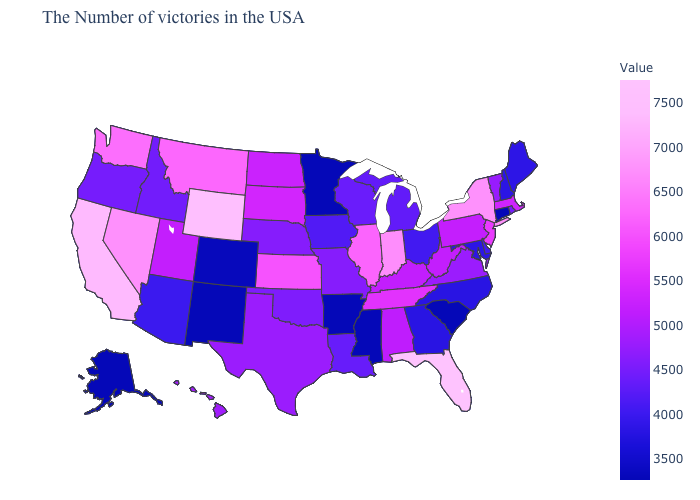Among the states that border Tennessee , which have the highest value?
Short answer required. Kentucky. Which states have the lowest value in the USA?
Give a very brief answer. Connecticut, South Carolina, Mississippi, Arkansas, Minnesota, New Mexico, Alaska. Which states have the lowest value in the South?
Quick response, please. South Carolina, Mississippi, Arkansas. Is the legend a continuous bar?
Write a very short answer. Yes. Which states hav the highest value in the South?
Be succinct. Florida. Which states hav the highest value in the MidWest?
Answer briefly. Indiana. Does Washington have a lower value than Wyoming?
Keep it brief. Yes. 